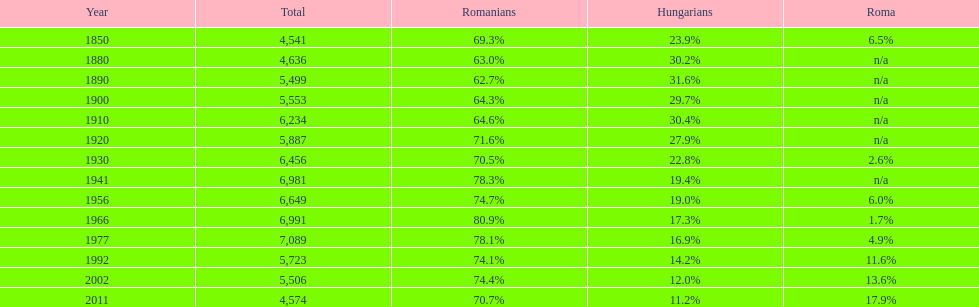Could you parse the entire table? {'header': ['Year', 'Total', 'Romanians', 'Hungarians', 'Roma'], 'rows': [['1850', '4,541', '69.3%', '23.9%', '6.5%'], ['1880', '4,636', '63.0%', '30.2%', 'n/a'], ['1890', '5,499', '62.7%', '31.6%', 'n/a'], ['1900', '5,553', '64.3%', '29.7%', 'n/a'], ['1910', '6,234', '64.6%', '30.4%', 'n/a'], ['1920', '5,887', '71.6%', '27.9%', 'n/a'], ['1930', '6,456', '70.5%', '22.8%', '2.6%'], ['1941', '6,981', '78.3%', '19.4%', 'n/a'], ['1956', '6,649', '74.7%', '19.0%', '6.0%'], ['1966', '6,991', '80.9%', '17.3%', '1.7%'], ['1977', '7,089', '78.1%', '16.9%', '4.9%'], ['1992', '5,723', '74.1%', '14.2%', '11.6%'], ['2002', '5,506', '74.4%', '12.0%', '13.6%'], ['2011', '4,574', '70.7%', '11.2%', '17.9%']]} Which year is previous to the year that had 74.1% in romanian population? 1977. 